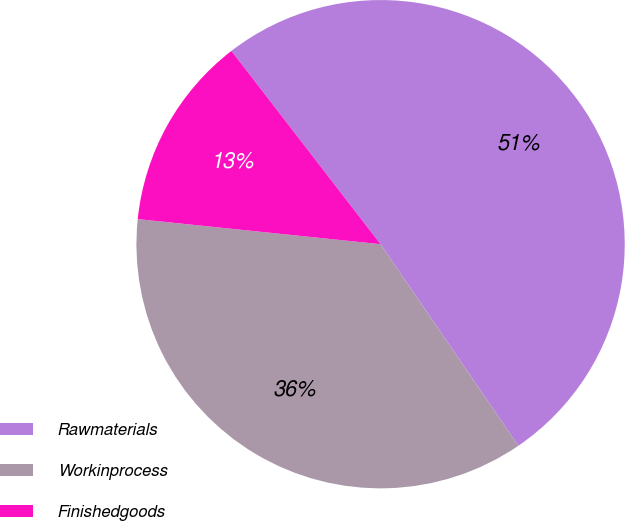<chart> <loc_0><loc_0><loc_500><loc_500><pie_chart><fcel>Rawmaterials<fcel>Workinprocess<fcel>Finishedgoods<nl><fcel>50.92%<fcel>36.18%<fcel>12.9%<nl></chart> 